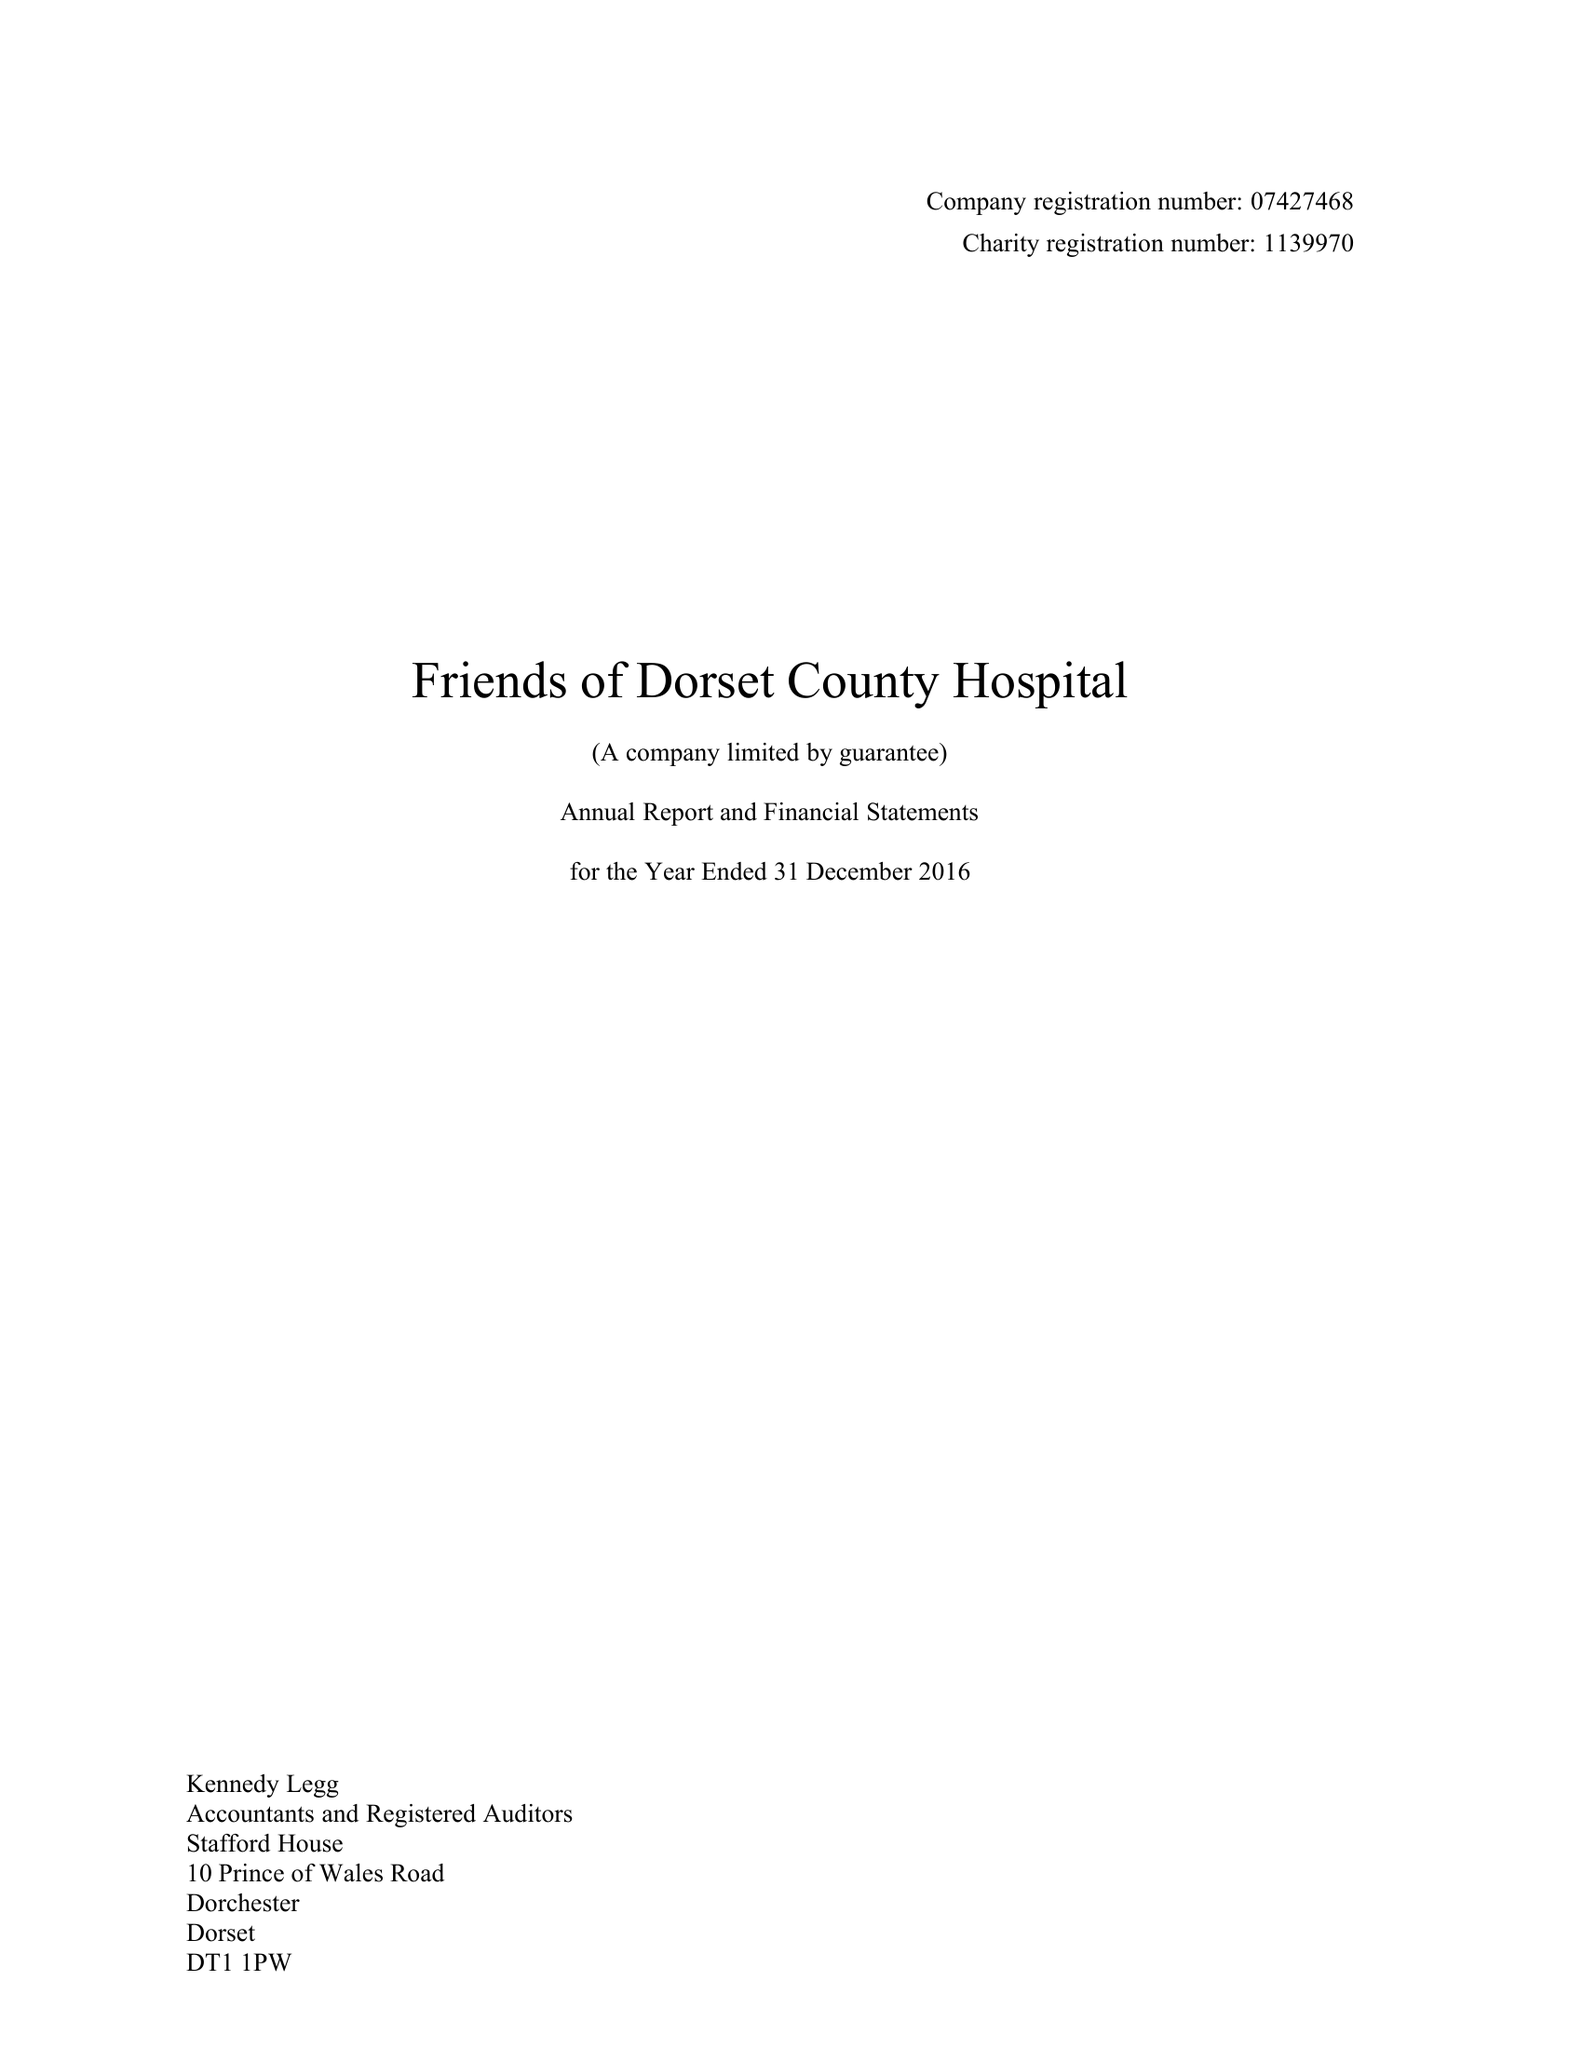What is the value for the address__postcode?
Answer the question using a single word or phrase. DT1 1PW 